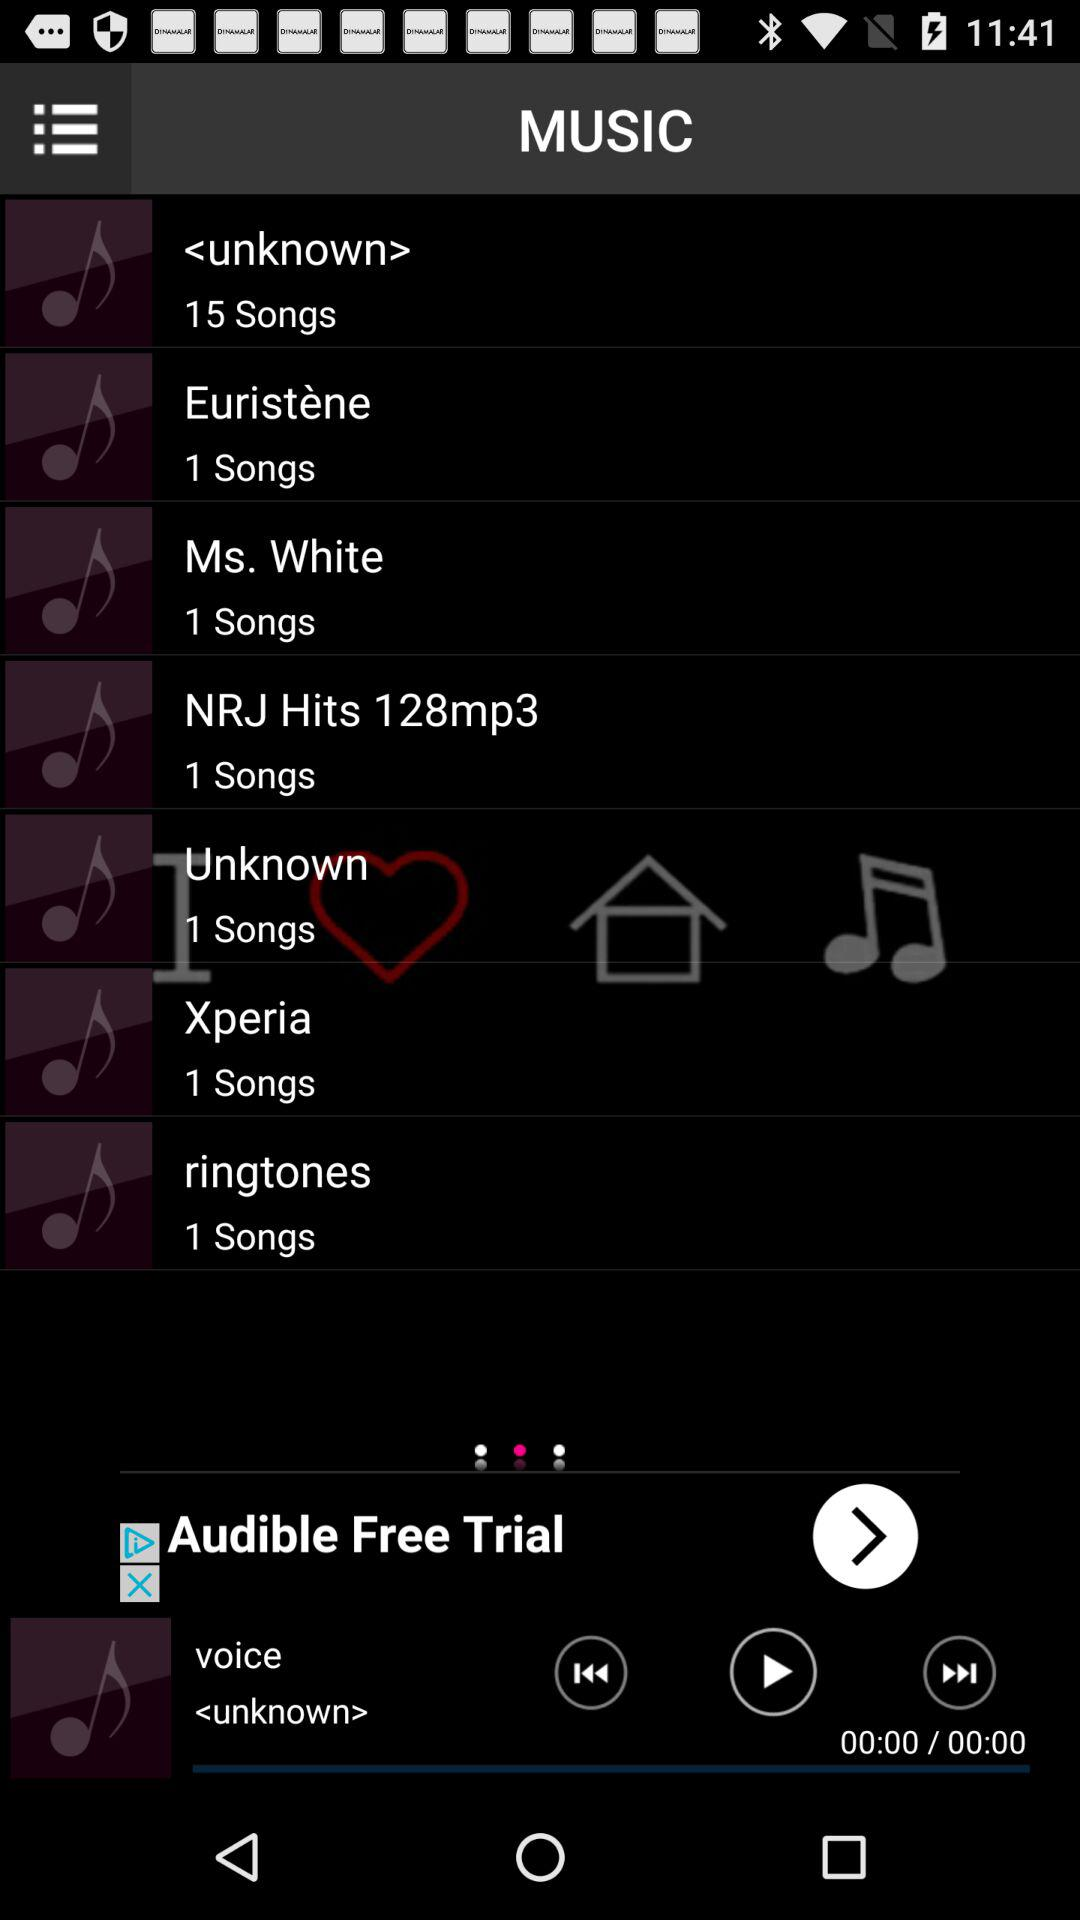How many songs are in the "Ms. White" album? There is 1 song in the "Ms. White" album. 